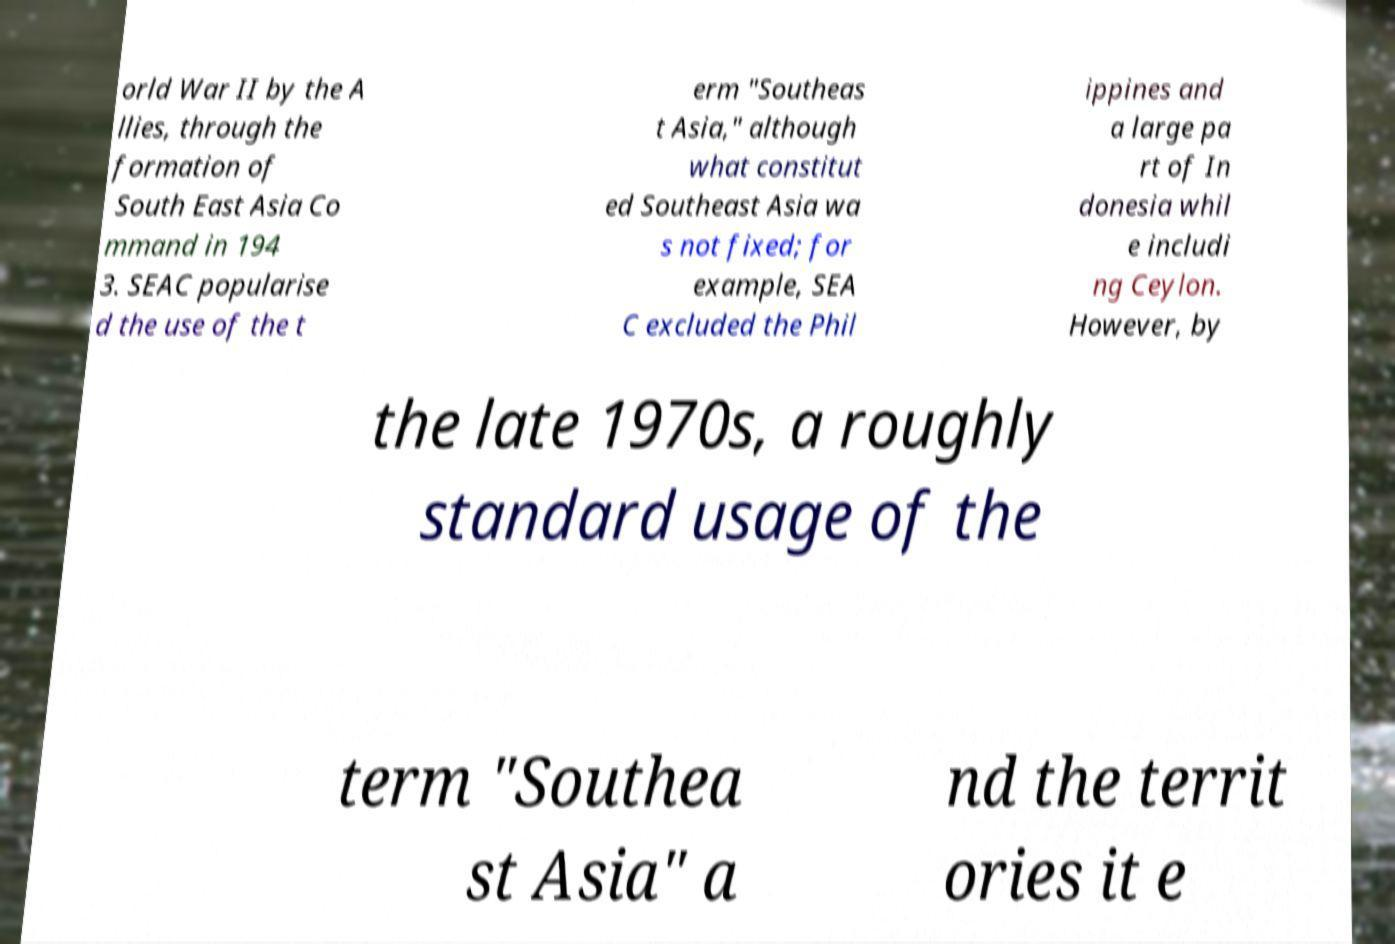What messages or text are displayed in this image? I need them in a readable, typed format. orld War II by the A llies, through the formation of South East Asia Co mmand in 194 3. SEAC popularise d the use of the t erm "Southeas t Asia," although what constitut ed Southeast Asia wa s not fixed; for example, SEA C excluded the Phil ippines and a large pa rt of In donesia whil e includi ng Ceylon. However, by the late 1970s, a roughly standard usage of the term "Southea st Asia" a nd the territ ories it e 